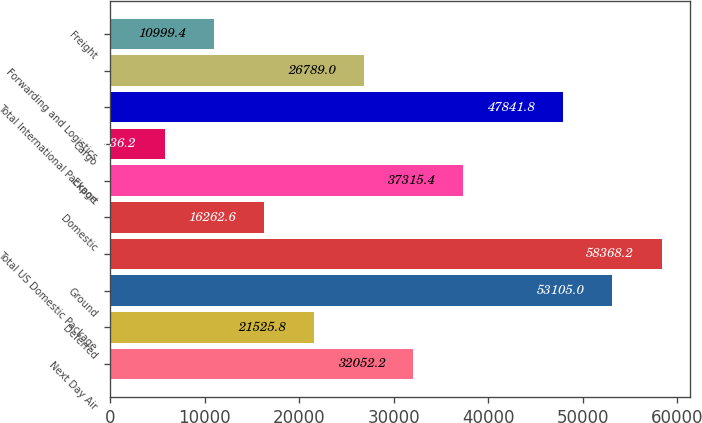<chart> <loc_0><loc_0><loc_500><loc_500><bar_chart><fcel>Next Day Air<fcel>Deferred<fcel>Ground<fcel>Total US Domestic Package<fcel>Domestic<fcel>Export<fcel>Cargo<fcel>Total International Package<fcel>Forwarding and Logistics<fcel>Freight<nl><fcel>32052.2<fcel>21525.8<fcel>53105<fcel>58368.2<fcel>16262.6<fcel>37315.4<fcel>5736.2<fcel>47841.8<fcel>26789<fcel>10999.4<nl></chart> 